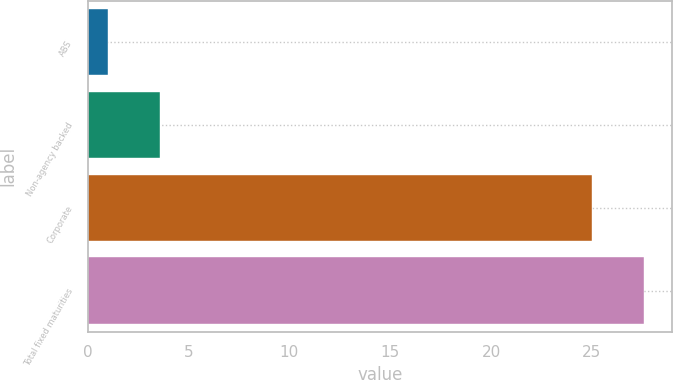Convert chart. <chart><loc_0><loc_0><loc_500><loc_500><bar_chart><fcel>ABS<fcel>Non-agency backed<fcel>Corporate<fcel>Total fixed maturities<nl><fcel>1<fcel>3.6<fcel>25<fcel>27.6<nl></chart> 